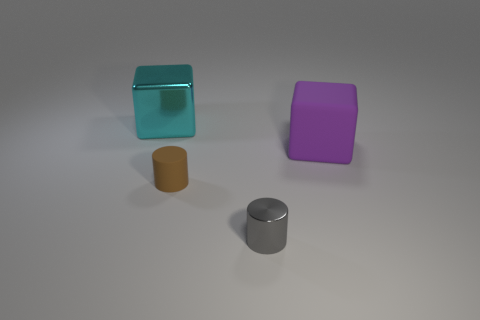What number of big objects are right of the metallic thing that is right of the cube to the left of the big purple rubber block?
Give a very brief answer. 1. There is another object that is the same shape as the purple matte object; what size is it?
Keep it short and to the point. Large. Is there anything else that has the same size as the gray cylinder?
Give a very brief answer. Yes. Is the number of cyan objects in front of the purple rubber object less than the number of large things?
Provide a short and direct response. Yes. Is the shape of the purple matte object the same as the cyan thing?
Make the answer very short. Yes. What color is the other object that is the same shape as the big rubber thing?
Give a very brief answer. Cyan. What number of objects are either large rubber cubes to the right of the gray shiny thing or large objects?
Your answer should be very brief. 2. What is the size of the block right of the large cyan shiny cube?
Your answer should be very brief. Large. Is the number of purple matte things less than the number of tiny objects?
Your answer should be compact. Yes. Is the block that is on the right side of the tiny brown rubber thing made of the same material as the tiny brown cylinder that is right of the metal cube?
Offer a terse response. Yes. 